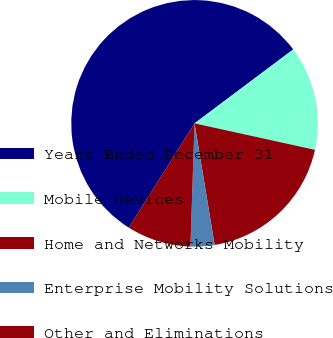Convert chart. <chart><loc_0><loc_0><loc_500><loc_500><pie_chart><fcel>Years Ended December 31<fcel>Mobile Devices<fcel>Home and Networks Mobility<fcel>Enterprise Mobility Solutions<fcel>Other and Eliminations<nl><fcel>55.82%<fcel>13.68%<fcel>18.95%<fcel>3.14%<fcel>8.41%<nl></chart> 